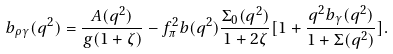Convert formula to latex. <formula><loc_0><loc_0><loc_500><loc_500>b _ { \rho \gamma } ( q ^ { 2 } ) = \frac { A ( q ^ { 2 } ) } { g ( 1 + \zeta ) } - f _ { \pi } ^ { 2 } b ( q ^ { 2 } ) \frac { \Sigma _ { 0 } ( q ^ { 2 } ) } { 1 + 2 \zeta } [ 1 + \frac { q ^ { 2 } b _ { \gamma } ( q ^ { 2 } ) } { 1 + \Sigma ( q ^ { 2 } ) } ] .</formula> 